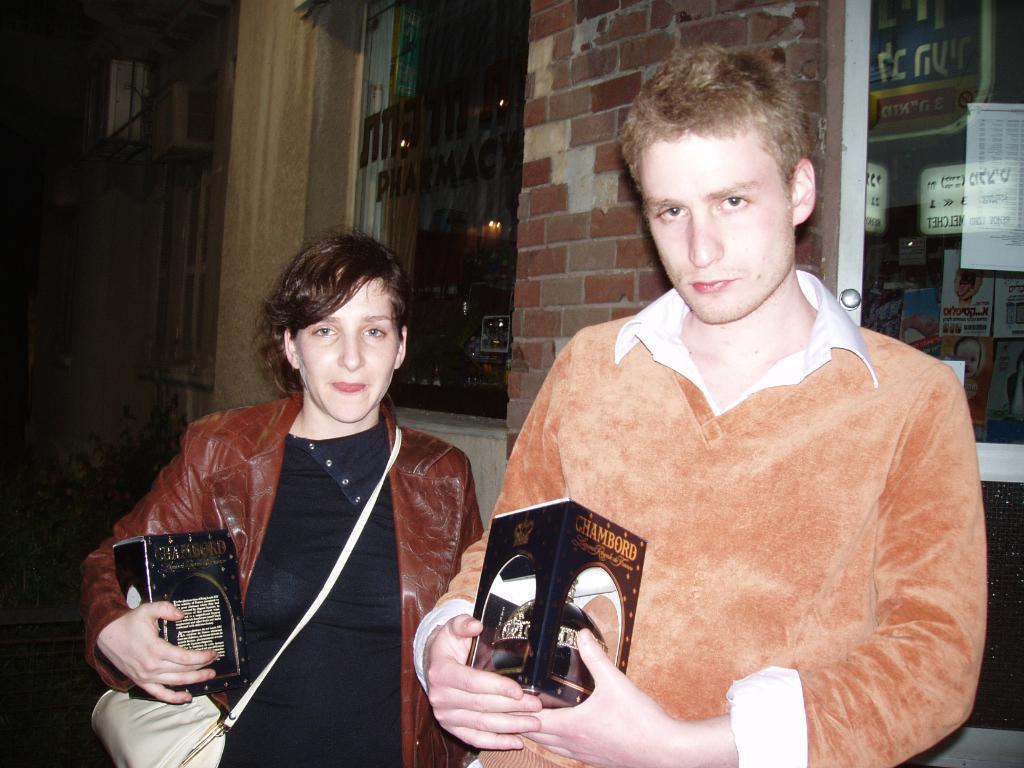Can you describe this image briefly? In this image on the right, there is a man, he wears a t shirt, he is holding a box. On the left there is a woman, she wears a jacket, handbag, she is holding a box. In the background there are windows, building, posters, glass and wall. 